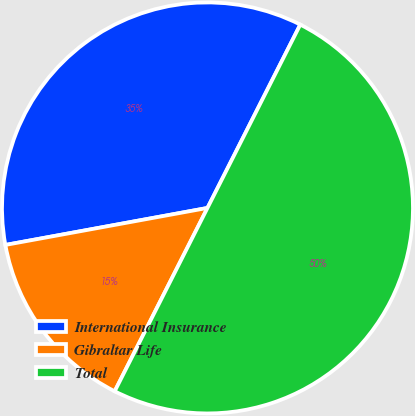Convert chart to OTSL. <chart><loc_0><loc_0><loc_500><loc_500><pie_chart><fcel>International Insurance<fcel>Gibraltar Life<fcel>Total<nl><fcel>35.34%<fcel>14.66%<fcel>50.0%<nl></chart> 